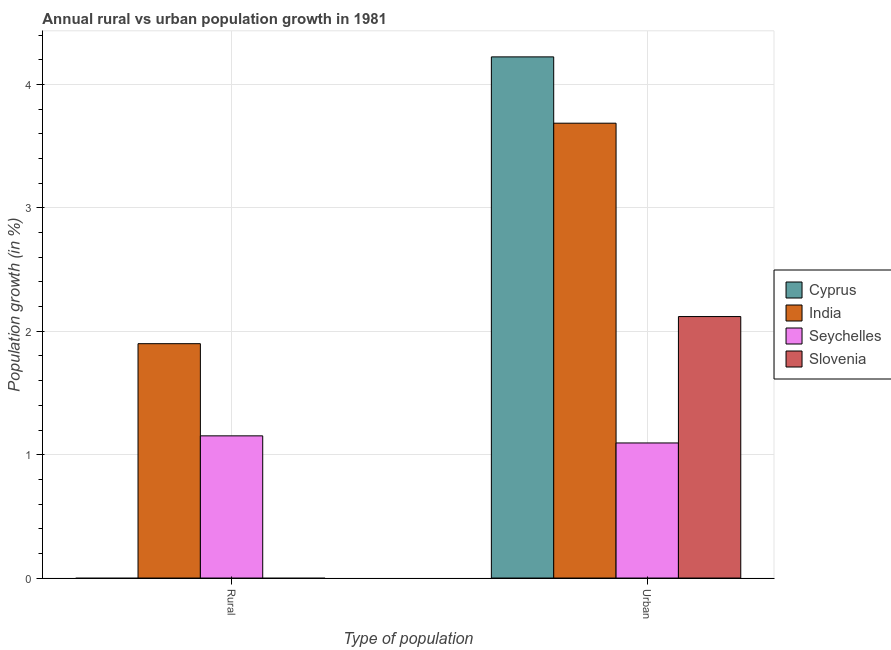How many groups of bars are there?
Ensure brevity in your answer.  2. Are the number of bars on each tick of the X-axis equal?
Provide a succinct answer. No. How many bars are there on the 1st tick from the left?
Keep it short and to the point. 2. What is the label of the 2nd group of bars from the left?
Offer a very short reply. Urban . What is the urban population growth in Cyprus?
Offer a terse response. 4.22. Across all countries, what is the maximum urban population growth?
Your answer should be very brief. 4.22. Across all countries, what is the minimum urban population growth?
Ensure brevity in your answer.  1.09. In which country was the urban population growth maximum?
Provide a succinct answer. Cyprus. What is the total urban population growth in the graph?
Give a very brief answer. 11.13. What is the difference between the urban population growth in India and that in Slovenia?
Keep it short and to the point. 1.57. What is the difference between the urban population growth in India and the rural population growth in Slovenia?
Give a very brief answer. 3.69. What is the average urban population growth per country?
Provide a short and direct response. 2.78. What is the difference between the rural population growth and urban population growth in India?
Your answer should be very brief. -1.79. In how many countries, is the rural population growth greater than 3.6 %?
Your answer should be very brief. 0. What is the ratio of the urban population growth in Cyprus to that in Seychelles?
Make the answer very short. 3.86. Are all the bars in the graph horizontal?
Your answer should be very brief. No. What is the difference between two consecutive major ticks on the Y-axis?
Offer a terse response. 1. Does the graph contain any zero values?
Offer a terse response. Yes. Where does the legend appear in the graph?
Give a very brief answer. Center right. How many legend labels are there?
Offer a very short reply. 4. What is the title of the graph?
Your answer should be compact. Annual rural vs urban population growth in 1981. Does "Korea (Republic)" appear as one of the legend labels in the graph?
Make the answer very short. No. What is the label or title of the X-axis?
Your response must be concise. Type of population. What is the label or title of the Y-axis?
Offer a very short reply. Population growth (in %). What is the Population growth (in %) in India in Rural?
Provide a short and direct response. 1.9. What is the Population growth (in %) of Seychelles in Rural?
Your answer should be compact. 1.15. What is the Population growth (in %) of Cyprus in Urban ?
Your answer should be very brief. 4.22. What is the Population growth (in %) of India in Urban ?
Offer a very short reply. 3.69. What is the Population growth (in %) in Seychelles in Urban ?
Your answer should be compact. 1.09. What is the Population growth (in %) of Slovenia in Urban ?
Your answer should be compact. 2.12. Across all Type of population, what is the maximum Population growth (in %) in Cyprus?
Offer a terse response. 4.22. Across all Type of population, what is the maximum Population growth (in %) of India?
Ensure brevity in your answer.  3.69. Across all Type of population, what is the maximum Population growth (in %) of Seychelles?
Your response must be concise. 1.15. Across all Type of population, what is the maximum Population growth (in %) of Slovenia?
Provide a short and direct response. 2.12. Across all Type of population, what is the minimum Population growth (in %) of India?
Your answer should be very brief. 1.9. Across all Type of population, what is the minimum Population growth (in %) of Seychelles?
Offer a very short reply. 1.09. What is the total Population growth (in %) in Cyprus in the graph?
Your response must be concise. 4.22. What is the total Population growth (in %) of India in the graph?
Keep it short and to the point. 5.59. What is the total Population growth (in %) of Seychelles in the graph?
Offer a very short reply. 2.25. What is the total Population growth (in %) of Slovenia in the graph?
Keep it short and to the point. 2.12. What is the difference between the Population growth (in %) of India in Rural and that in Urban ?
Your answer should be compact. -1.79. What is the difference between the Population growth (in %) of Seychelles in Rural and that in Urban ?
Your response must be concise. 0.06. What is the difference between the Population growth (in %) of India in Rural and the Population growth (in %) of Seychelles in Urban?
Keep it short and to the point. 0.8. What is the difference between the Population growth (in %) of India in Rural and the Population growth (in %) of Slovenia in Urban?
Make the answer very short. -0.22. What is the difference between the Population growth (in %) in Seychelles in Rural and the Population growth (in %) in Slovenia in Urban?
Your response must be concise. -0.97. What is the average Population growth (in %) of Cyprus per Type of population?
Your response must be concise. 2.11. What is the average Population growth (in %) in India per Type of population?
Make the answer very short. 2.79. What is the average Population growth (in %) in Seychelles per Type of population?
Ensure brevity in your answer.  1.12. What is the average Population growth (in %) of Slovenia per Type of population?
Provide a succinct answer. 1.06. What is the difference between the Population growth (in %) in India and Population growth (in %) in Seychelles in Rural?
Provide a short and direct response. 0.75. What is the difference between the Population growth (in %) of Cyprus and Population growth (in %) of India in Urban ?
Give a very brief answer. 0.54. What is the difference between the Population growth (in %) in Cyprus and Population growth (in %) in Seychelles in Urban ?
Offer a very short reply. 3.13. What is the difference between the Population growth (in %) in Cyprus and Population growth (in %) in Slovenia in Urban ?
Your answer should be compact. 2.1. What is the difference between the Population growth (in %) in India and Population growth (in %) in Seychelles in Urban ?
Offer a very short reply. 2.59. What is the difference between the Population growth (in %) of India and Population growth (in %) of Slovenia in Urban ?
Make the answer very short. 1.57. What is the difference between the Population growth (in %) in Seychelles and Population growth (in %) in Slovenia in Urban ?
Offer a very short reply. -1.02. What is the ratio of the Population growth (in %) in India in Rural to that in Urban ?
Your answer should be compact. 0.52. What is the ratio of the Population growth (in %) of Seychelles in Rural to that in Urban ?
Your response must be concise. 1.05. What is the difference between the highest and the second highest Population growth (in %) of India?
Your response must be concise. 1.79. What is the difference between the highest and the second highest Population growth (in %) of Seychelles?
Make the answer very short. 0.06. What is the difference between the highest and the lowest Population growth (in %) of Cyprus?
Offer a very short reply. 4.22. What is the difference between the highest and the lowest Population growth (in %) of India?
Ensure brevity in your answer.  1.79. What is the difference between the highest and the lowest Population growth (in %) in Seychelles?
Ensure brevity in your answer.  0.06. What is the difference between the highest and the lowest Population growth (in %) of Slovenia?
Offer a terse response. 2.12. 